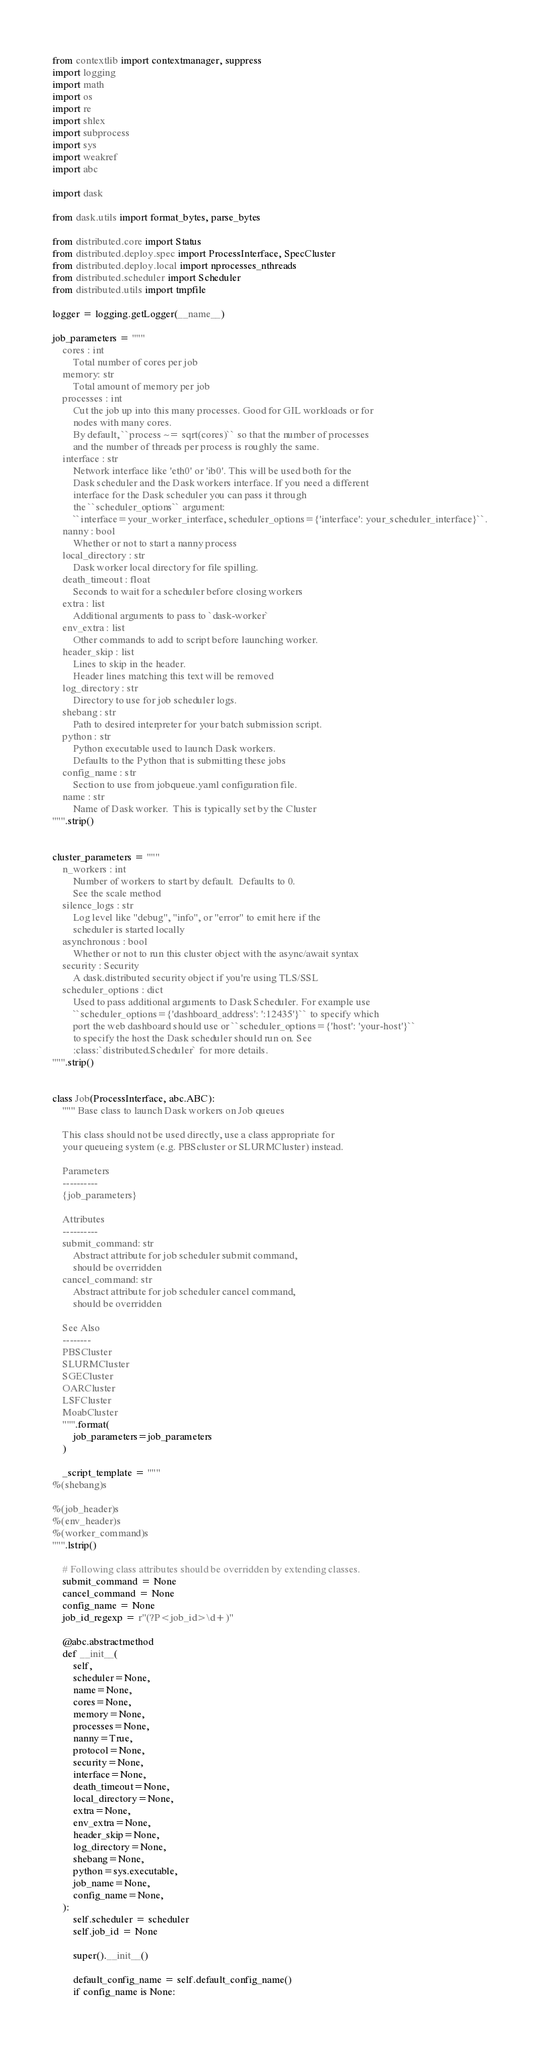Convert code to text. <code><loc_0><loc_0><loc_500><loc_500><_Python_>from contextlib import contextmanager, suppress
import logging
import math
import os
import re
import shlex
import subprocess
import sys
import weakref
import abc

import dask

from dask.utils import format_bytes, parse_bytes

from distributed.core import Status
from distributed.deploy.spec import ProcessInterface, SpecCluster
from distributed.deploy.local import nprocesses_nthreads
from distributed.scheduler import Scheduler
from distributed.utils import tmpfile

logger = logging.getLogger(__name__)

job_parameters = """
    cores : int
        Total number of cores per job
    memory: str
        Total amount of memory per job
    processes : int
        Cut the job up into this many processes. Good for GIL workloads or for
        nodes with many cores.
        By default, ``process ~= sqrt(cores)`` so that the number of processes
        and the number of threads per process is roughly the same.
    interface : str
        Network interface like 'eth0' or 'ib0'. This will be used both for the
        Dask scheduler and the Dask workers interface. If you need a different
        interface for the Dask scheduler you can pass it through
        the ``scheduler_options`` argument:
        ``interface=your_worker_interface, scheduler_options={'interface': your_scheduler_interface}``.
    nanny : bool
        Whether or not to start a nanny process
    local_directory : str
        Dask worker local directory for file spilling.
    death_timeout : float
        Seconds to wait for a scheduler before closing workers
    extra : list
        Additional arguments to pass to `dask-worker`
    env_extra : list
        Other commands to add to script before launching worker.
    header_skip : list
        Lines to skip in the header.
        Header lines matching this text will be removed
    log_directory : str
        Directory to use for job scheduler logs.
    shebang : str
        Path to desired interpreter for your batch submission script.
    python : str
        Python executable used to launch Dask workers.
        Defaults to the Python that is submitting these jobs
    config_name : str
        Section to use from jobqueue.yaml configuration file.
    name : str
        Name of Dask worker.  This is typically set by the Cluster
""".strip()


cluster_parameters = """
    n_workers : int
        Number of workers to start by default.  Defaults to 0.
        See the scale method
    silence_logs : str
        Log level like "debug", "info", or "error" to emit here if the
        scheduler is started locally
    asynchronous : bool
        Whether or not to run this cluster object with the async/await syntax
    security : Security
        A dask.distributed security object if you're using TLS/SSL
    scheduler_options : dict
        Used to pass additional arguments to Dask Scheduler. For example use
        ``scheduler_options={'dashboard_address': ':12435'}`` to specify which
        port the web dashboard should use or ``scheduler_options={'host': 'your-host'}``
        to specify the host the Dask scheduler should run on. See
        :class:`distributed.Scheduler` for more details.
""".strip()


class Job(ProcessInterface, abc.ABC):
    """ Base class to launch Dask workers on Job queues

    This class should not be used directly, use a class appropriate for
    your queueing system (e.g. PBScluster or SLURMCluster) instead.

    Parameters
    ----------
    {job_parameters}

    Attributes
    ----------
    submit_command: str
        Abstract attribute for job scheduler submit command,
        should be overridden
    cancel_command: str
        Abstract attribute for job scheduler cancel command,
        should be overridden

    See Also
    --------
    PBSCluster
    SLURMCluster
    SGECluster
    OARCluster
    LSFCluster
    MoabCluster
    """.format(
        job_parameters=job_parameters
    )

    _script_template = """
%(shebang)s

%(job_header)s
%(env_header)s
%(worker_command)s
""".lstrip()

    # Following class attributes should be overridden by extending classes.
    submit_command = None
    cancel_command = None
    config_name = None
    job_id_regexp = r"(?P<job_id>\d+)"

    @abc.abstractmethod
    def __init__(
        self,
        scheduler=None,
        name=None,
        cores=None,
        memory=None,
        processes=None,
        nanny=True,
        protocol=None,
        security=None,
        interface=None,
        death_timeout=None,
        local_directory=None,
        extra=None,
        env_extra=None,
        header_skip=None,
        log_directory=None,
        shebang=None,
        python=sys.executable,
        job_name=None,
        config_name=None,
    ):
        self.scheduler = scheduler
        self.job_id = None

        super().__init__()

        default_config_name = self.default_config_name()
        if config_name is None:</code> 